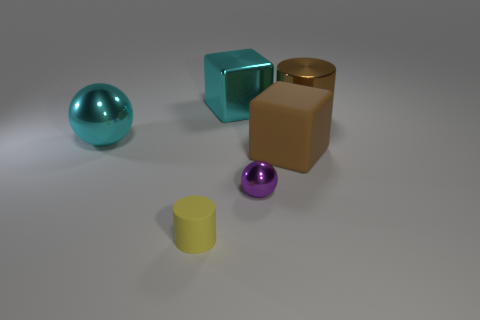Add 2 yellow matte cylinders. How many objects exist? 8 Subtract all cylinders. How many objects are left? 4 Subtract all metallic blocks. Subtract all cyan shiny blocks. How many objects are left? 4 Add 4 large brown matte objects. How many large brown matte objects are left? 5 Add 2 cyan metallic spheres. How many cyan metallic spheres exist? 3 Subtract 1 brown cylinders. How many objects are left? 5 